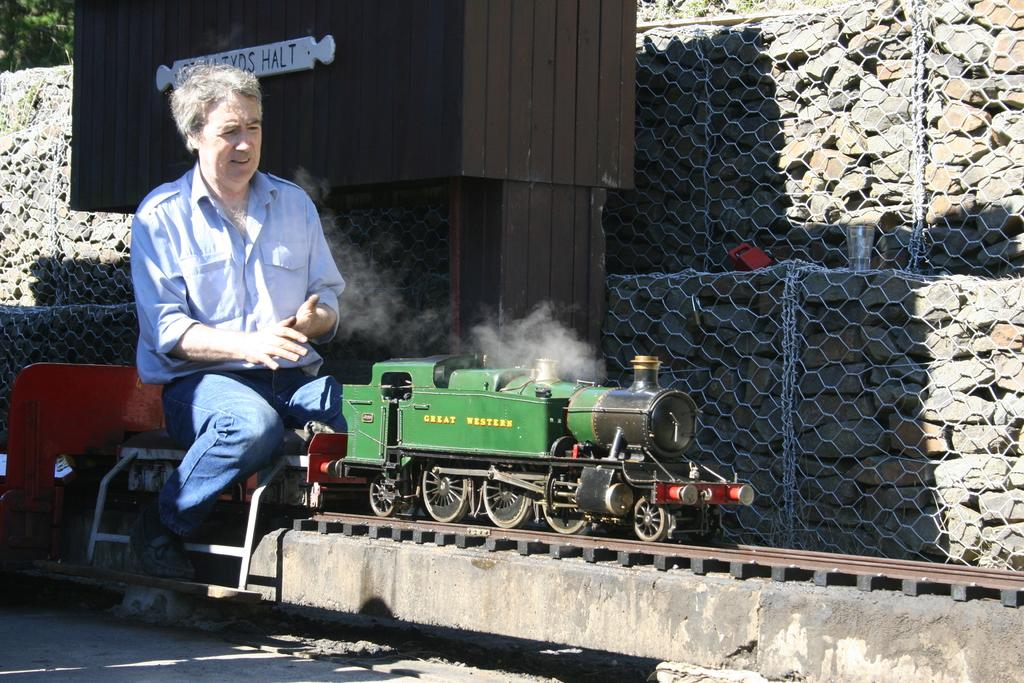What is the main feature of the image? There is a railway track in the image. What is on the railway track? There is a train on the railway track. Can you describe the train's occupants? A man is sitting on the train. What other structures are visible in the image? There is a fence and a wall in the image. What type of trousers is the train wearing in the image? Trains do not wear trousers, as they are inanimate objects. --- Facts: 1. There is a river in the image. 2. There are trees on both sides of the river. 3. The water in the river is flowing. 4. There is a bridge over the river. 5. The sky is visible in the image. Absurd Topics: bicycle, parrot, ladder Conversation: What is the main feature of the image? There is a river in the image. What can be seen on both sides of the river? There are trees on both sides of the river. How is the water in the river moving? The water in the river is flowing. What is built over the river? There is a bridge over the river. What is visible in the sky in the image? The sky is visible in the image. Reasoning: Let's think step by step in order to produce the conversation. We start by identifying the main subject of the image, which is the river. Then, we describe the trees on both sides of the river and mention the flowing water. Next, we acknowledge the presence of the bridge over the river and the visible sky. Absurd Question/Answer: Can you tell me how many parrots are sitting on the bicycle in the image? There is no bicycle or parrot present in the image. --- Facts: 1. There is a car in the image. 2. The car is parked on the street. 3. There are people walking on the sidewalk. 4. There is a streetlight in the image. 5. The sky is visible in the image. Absurd Topics: piano, elephant, balloon Conversation: What is the main subject of the image? There is a car in the image. Where is the car located? The car is parked on the street. What can be seen on the sidewalk? There are people walking on the sidewalk. What structure is present in the image to provide illumination at night? There is a streetlight in the image. What is visible in the sky in the image? The sky is visible in the image. Reasoning: Let's think step by step in order to produce the conversation. We start by identifying the main subject of the image, which is the car. Then, we describe the car's location and mention the people walking on the sidewalk. 